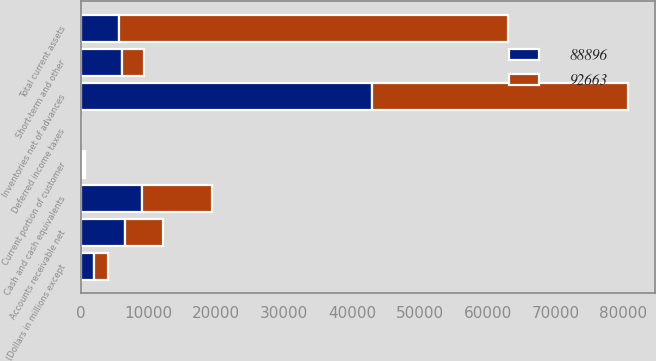<chart> <loc_0><loc_0><loc_500><loc_500><stacked_bar_chart><ecel><fcel>(Dollars in millions except<fcel>Cash and cash equivalents<fcel>Short-term and other<fcel>Accounts receivable net<fcel>Current portion of customer<fcel>Deferred income taxes<fcel>Inventories net of advances<fcel>Total current assets<nl><fcel>88896<fcel>2013<fcel>9088<fcel>6170<fcel>6546<fcel>344<fcel>14<fcel>42912<fcel>5608<nl><fcel>92663<fcel>2012<fcel>10341<fcel>3217<fcel>5608<fcel>364<fcel>28<fcel>37751<fcel>57309<nl></chart> 